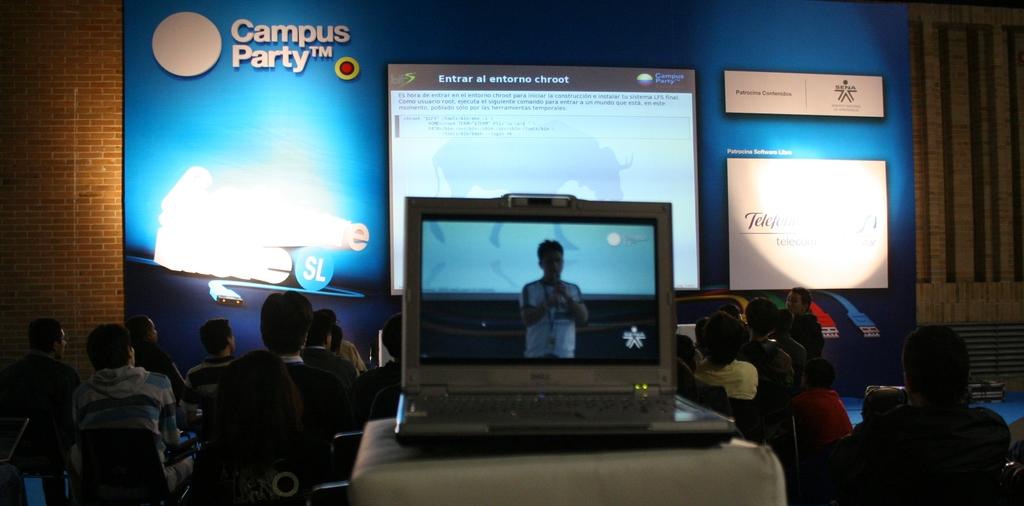What is the title of this slideshow?
Offer a terse response. Campus party. What name is tradmarked in the upper left?
Keep it short and to the point. Campus party. 